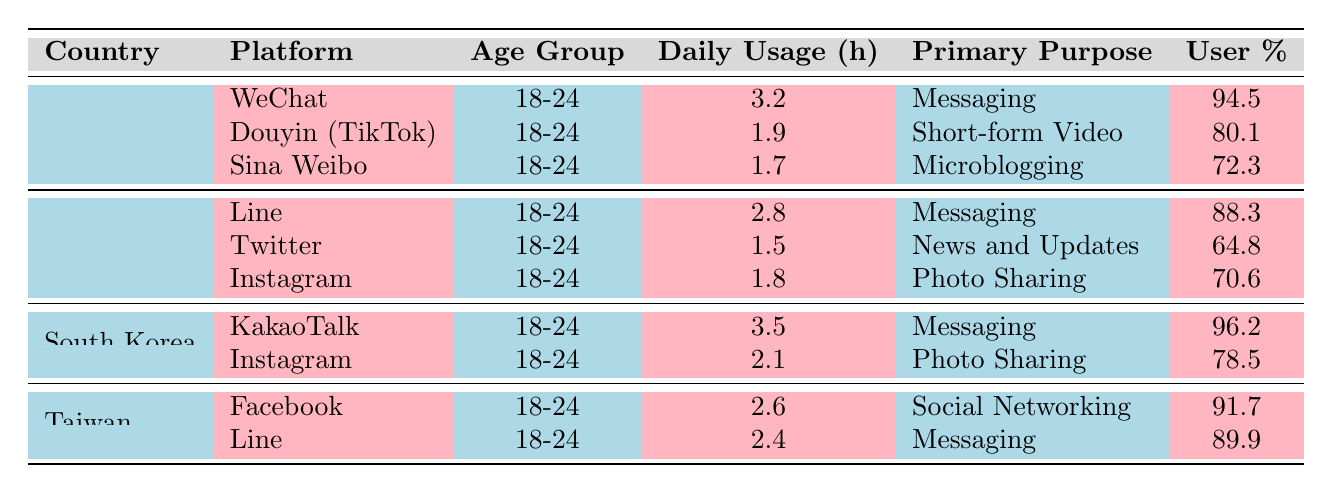What is the most used social media platform among young adults in South Korea? The table shows that KakaoTalk has a user percentage of 96.2, which is the highest for any platform among South Korean young adults.
Answer: KakaoTalk How many daily usage hours does Instagram have among young adults in Japan? The table indicates that Instagram has 1.8 daily usage hours for young adults in Japan.
Answer: 1.8 hours Which platform has the lowest user percentage among young adults in China? In China, Sina Weibo has a user percentage of 72.3, which is lower than WeChat (94.5) and Douyin (80.1).
Answer: Sina Weibo What is the average daily usage hours of messaging platforms in the table? The messaging platforms listed are WeChat (3.2), Line (2.8), KakaoTalk (3.5), and Line (2.4). Adding these gives 3.2 + 2.8 + 3.5 + 2.4 = 12. Meanwhile, the number of messaging platforms is 4, so the average is 12/4 = 3.0 hours.
Answer: 3.0 hours Is the user percentage for Douyin (TikTok) in China above 75%? The table lists Douyin (TikTok) with a user percentage of 80.1, which is indeed above 75%.
Answer: Yes Which country's youth have the highest daily usage of social media? South Korea's KakaoTalk has the highest daily usage hours at 3.5 among the platforms listed for youth, indicating it is the country with the highest daily usage in the table.
Answer: South Korea What is the difference in daily usage hours between WeChat and Douyin (TikTok) in China? WeChat has 3.2 hours and Douyin (TikTok) has 1.9 hours. The difference is calculated as 3.2 - 1.9 = 1.3 hours.
Answer: 1.3 hours How many platforms show a user percentage of over 80% across all countries listed? The platforms with user percentages over 80% are WeChat (94.5), KakaoTalk (96.2), Douyin (TikTok) (80.1), and Line (89.9). Thus, there are 4 platforms in total.
Answer: 4 platforms What is the primary purpose of the most used platform in Japan according to the table? The most used platform in Japan is Line with 88.3% user percentage, and its primary purpose is messaging.
Answer: Messaging Was Instagram used more by young adults in Taiwan than in Japan? In Taiwan, Instagram isn't listed, but the primary messaging platform, Line, has a user percentage of 89.9%. In Japan, Instagram has a user percentage of 70.6%. Therefore, the answer is yes.
Answer: Yes 